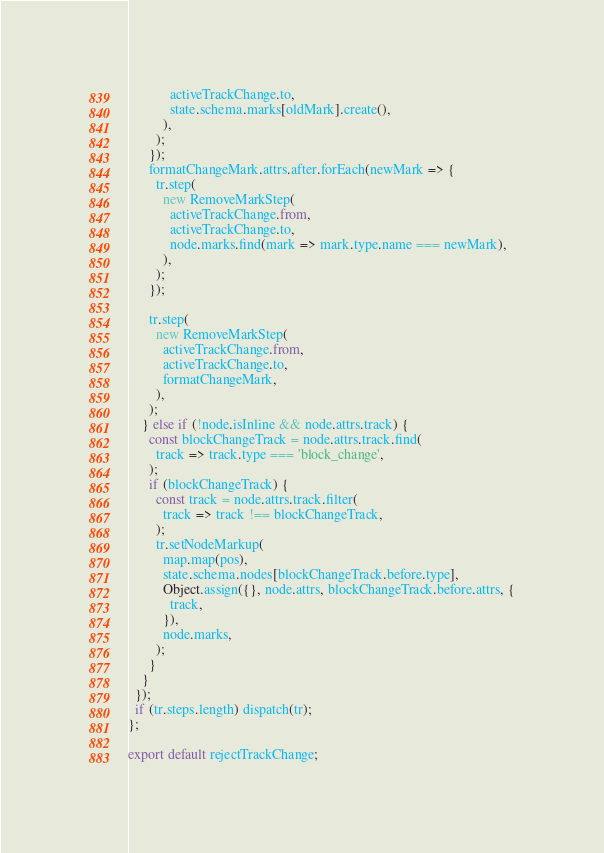<code> <loc_0><loc_0><loc_500><loc_500><_JavaScript_>            activeTrackChange.to,
            state.schema.marks[oldMark].create(),
          ),
        );
      });
      formatChangeMark.attrs.after.forEach(newMark => {
        tr.step(
          new RemoveMarkStep(
            activeTrackChange.from,
            activeTrackChange.to,
            node.marks.find(mark => mark.type.name === newMark),
          ),
        );
      });

      tr.step(
        new RemoveMarkStep(
          activeTrackChange.from,
          activeTrackChange.to,
          formatChangeMark,
        ),
      );
    } else if (!node.isInline && node.attrs.track) {
      const blockChangeTrack = node.attrs.track.find(
        track => track.type === 'block_change',
      );
      if (blockChangeTrack) {
        const track = node.attrs.track.filter(
          track => track !== blockChangeTrack,
        );
        tr.setNodeMarkup(
          map.map(pos),
          state.schema.nodes[blockChangeTrack.before.type],
          Object.assign({}, node.attrs, blockChangeTrack.before.attrs, {
            track,
          }),
          node.marks,
        );
      }
    }
  });
  if (tr.steps.length) dispatch(tr);
};

export default rejectTrackChange;
</code> 